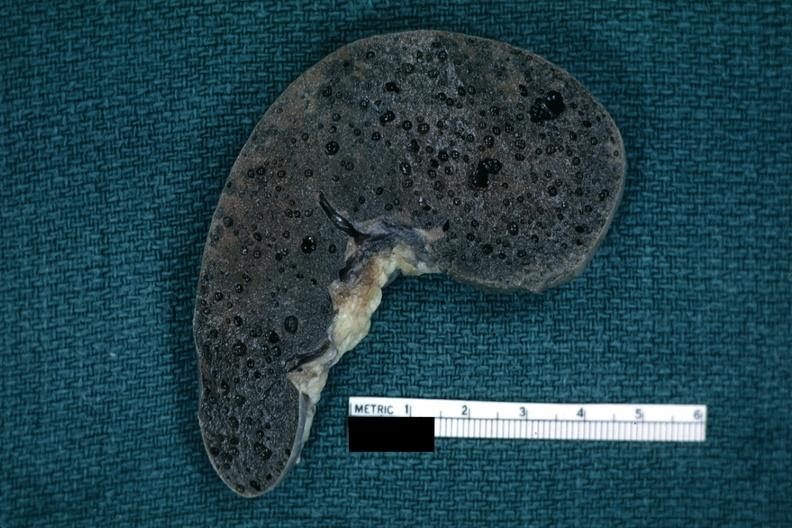what is present?
Answer the question using a single word or phrase. Spleen 